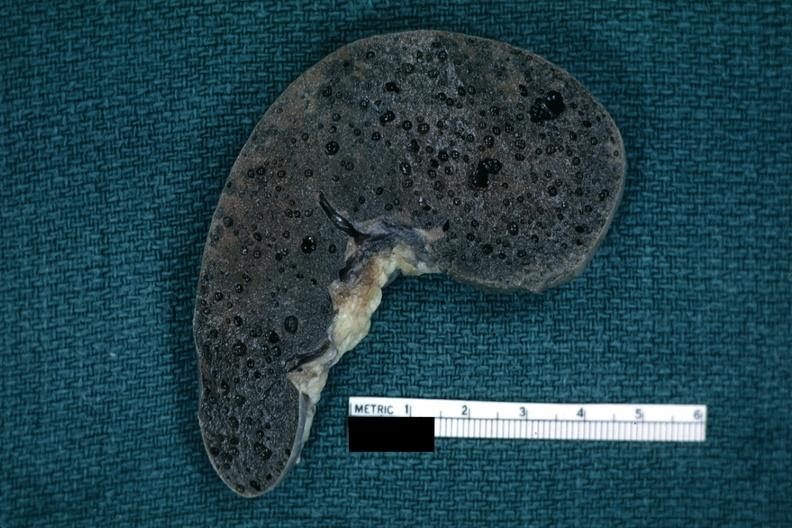what is present?
Answer the question using a single word or phrase. Spleen 